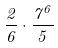Convert formula to latex. <formula><loc_0><loc_0><loc_500><loc_500>\frac { 2 } { 6 } \cdot \frac { 7 ^ { 6 } } { 5 }</formula> 